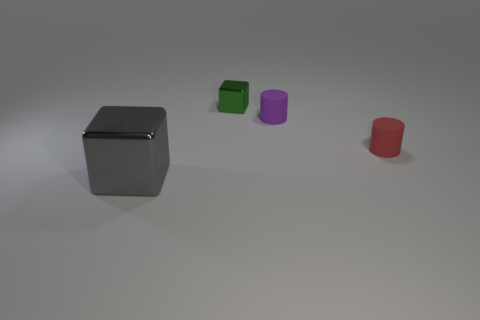Add 1 big gray spheres. How many objects exist? 5 Subtract 0 gray cylinders. How many objects are left? 4 Subtract all big purple cylinders. Subtract all large shiny blocks. How many objects are left? 3 Add 4 metal things. How many metal things are left? 6 Add 1 small red matte objects. How many small red matte objects exist? 2 